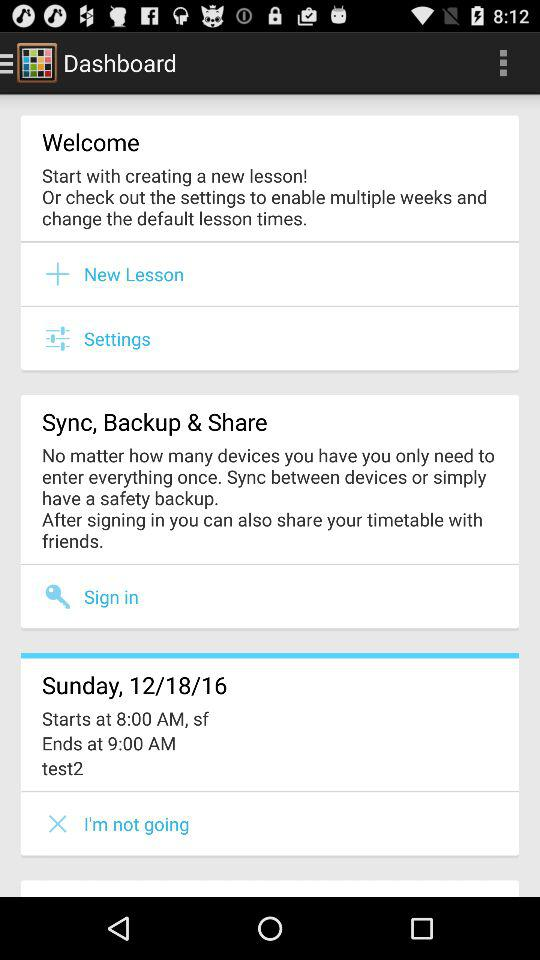On which day is "test2" scheduled? The day is Sunday. 